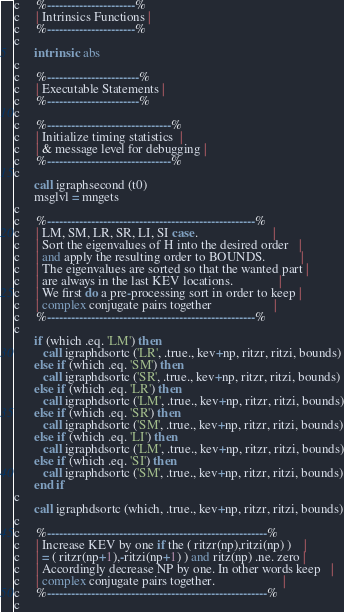<code> <loc_0><loc_0><loc_500><loc_500><_FORTRAN_>c     %----------------------%
c     | Intrinsics Functions |
c     %----------------------%
c
      intrinsic  abs
c
c     %-----------------------%
c     | Executable Statements |
c     %-----------------------%
c
c     %-------------------------------%
c     | Initialize timing statistics  |
c     | & message level for debugging |
c     %-------------------------------%
c 
      call igraphsecond (t0)
      msglvl = mngets
c 
c     %----------------------------------------------------%
c     | LM, SM, LR, SR, LI, SI case.                       |
c     | Sort the eigenvalues of H into the desired order   |
c     | and apply the resulting order to BOUNDS.           |
c     | The eigenvalues are sorted so that the wanted part |
c     | are always in the last KEV locations.              |
c     | We first do a pre-processing sort in order to keep |
c     | complex conjugate pairs together                   |
c     %----------------------------------------------------%
c
      if (which .eq. 'LM') then
         call igraphdsortc ('LR', .true., kev+np, ritzr, ritzi, bounds)
      else if (which .eq. 'SM') then
         call igraphdsortc ('SR', .true., kev+np, ritzr, ritzi, bounds)
      else if (which .eq. 'LR') then
         call igraphdsortc ('LM', .true., kev+np, ritzr, ritzi, bounds)
      else if (which .eq. 'SR') then
         call igraphdsortc ('SM', .true., kev+np, ritzr, ritzi, bounds)
      else if (which .eq. 'LI') then
         call igraphdsortc ('LM', .true., kev+np, ritzr, ritzi, bounds)
      else if (which .eq. 'SI') then
         call igraphdsortc ('SM', .true., kev+np, ritzr, ritzi, bounds)
      end if
c      
      call igraphdsortc (which, .true., kev+np, ritzr, ritzi, bounds)
c     
c     %-------------------------------------------------------%
c     | Increase KEV by one if the ( ritzr(np),ritzi(np) )    |
c     | = ( ritzr(np+1),-ritzi(np+1) ) and ritz(np) .ne. zero |
c     | Accordingly decrease NP by one. In other words keep   |
c     | complex conjugate pairs together.                     |
c     %-------------------------------------------------------%
c     </code> 